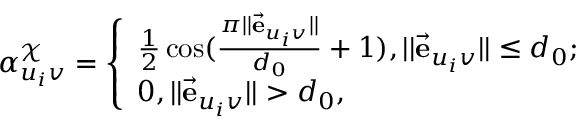<formula> <loc_0><loc_0><loc_500><loc_500>\alpha _ { u _ { i } v } ^ { \mathcal { X } } = \left \{ \begin{array} { l l } { \frac { 1 } { 2 } \cos ( \frac { \pi | | \vec { e } _ { u _ { i } v } | | } { d _ { 0 } } + 1 ) , | | \vec { e } _ { u _ { i } v } | | \leq d _ { 0 } ; } \\ { 0 , | | \vec { e } _ { u _ { i } v } | | > d _ { 0 } , } \end{array}</formula> 